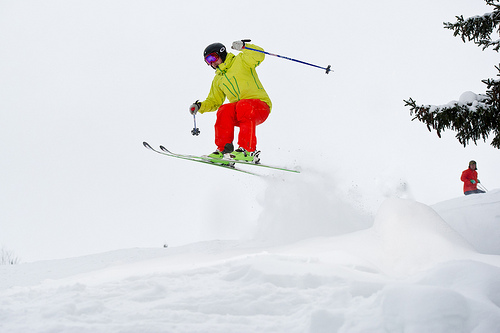Please provide the bounding box coordinate of the region this sentence describes: a tree on the side of the hill. The bounding box for the tree on the side of the snow-covered hill is [0.78, 0.18, 1.0, 0.46]. 